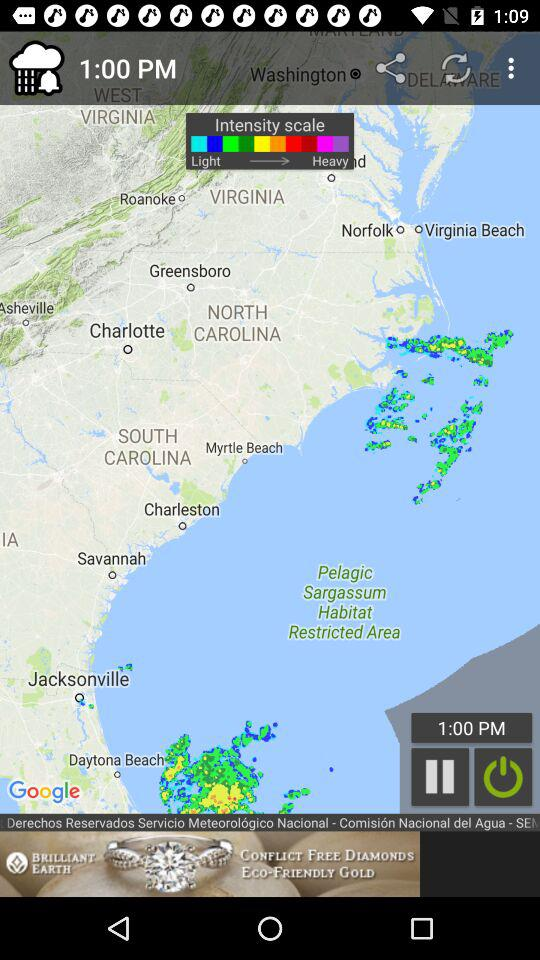What is the shown time? The shown time is 1:00 PM. 